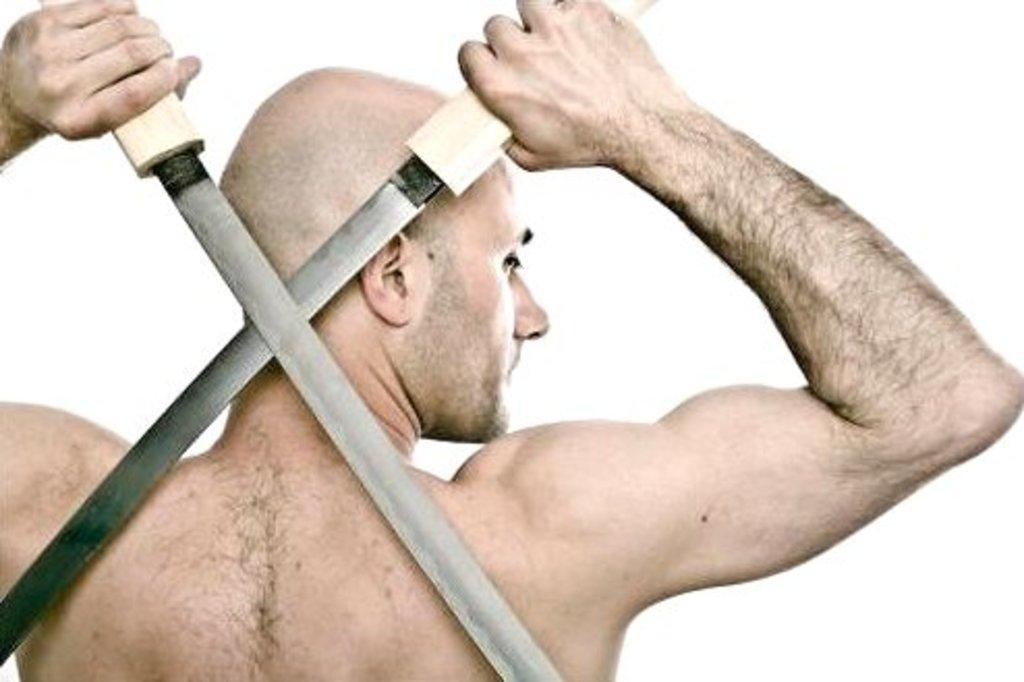Who is present in the image? There is a man in the image. What is the man holding in the image? The man is holding swords. What color is the background of the image? The background of the image is white in color. What type of cabbage is the man using to defend himself in the image? There is no cabbage present in the image; the man is holding swords. What emotion does the man appear to be experiencing in the image? The image does not provide any information about the man's emotions, so it cannot be determined from the image. 